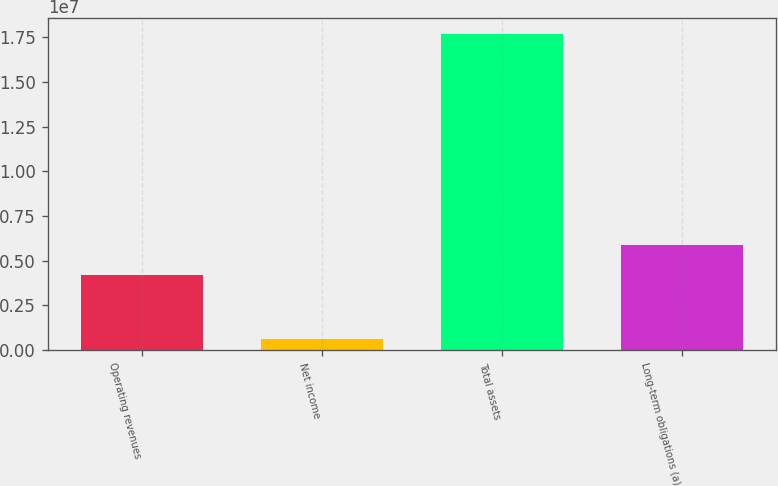<chart> <loc_0><loc_0><loc_500><loc_500><bar_chart><fcel>Operating revenues<fcel>Net income<fcel>Total assets<fcel>Long-term obligations (a)<nl><fcel>4.17705e+06<fcel>622047<fcel>1.77013e+07<fcel>5.88497e+06<nl></chart> 